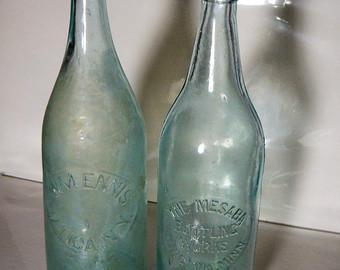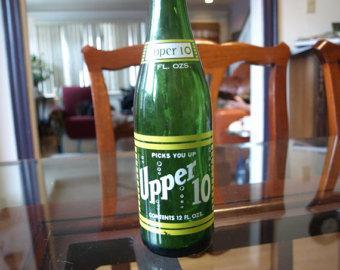The first image is the image on the left, the second image is the image on the right. Assess this claim about the two images: "There are three glass bottles in the left image.". Correct or not? Answer yes or no. No. The first image is the image on the left, the second image is the image on the right. For the images displayed, is the sentence "There are at most 3 bottles in the image pair." factually correct? Answer yes or no. Yes. 